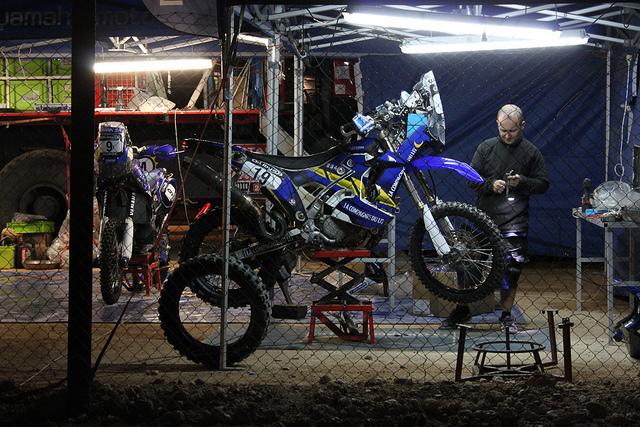Can you drive the motorcycle in this position?
Answer briefly. No. What number does the bike have on the side?
Concise answer only. 19. What is the tent for?
Short answer required. Cover. How many green objects are in the picture?
Keep it brief. 1. Is this an unusually large number of parked bikes in one place?
Answer briefly. No. Is this bike being repaired?
Answer briefly. Yes. Is the boy a biker?
Quick response, please. Yes. 